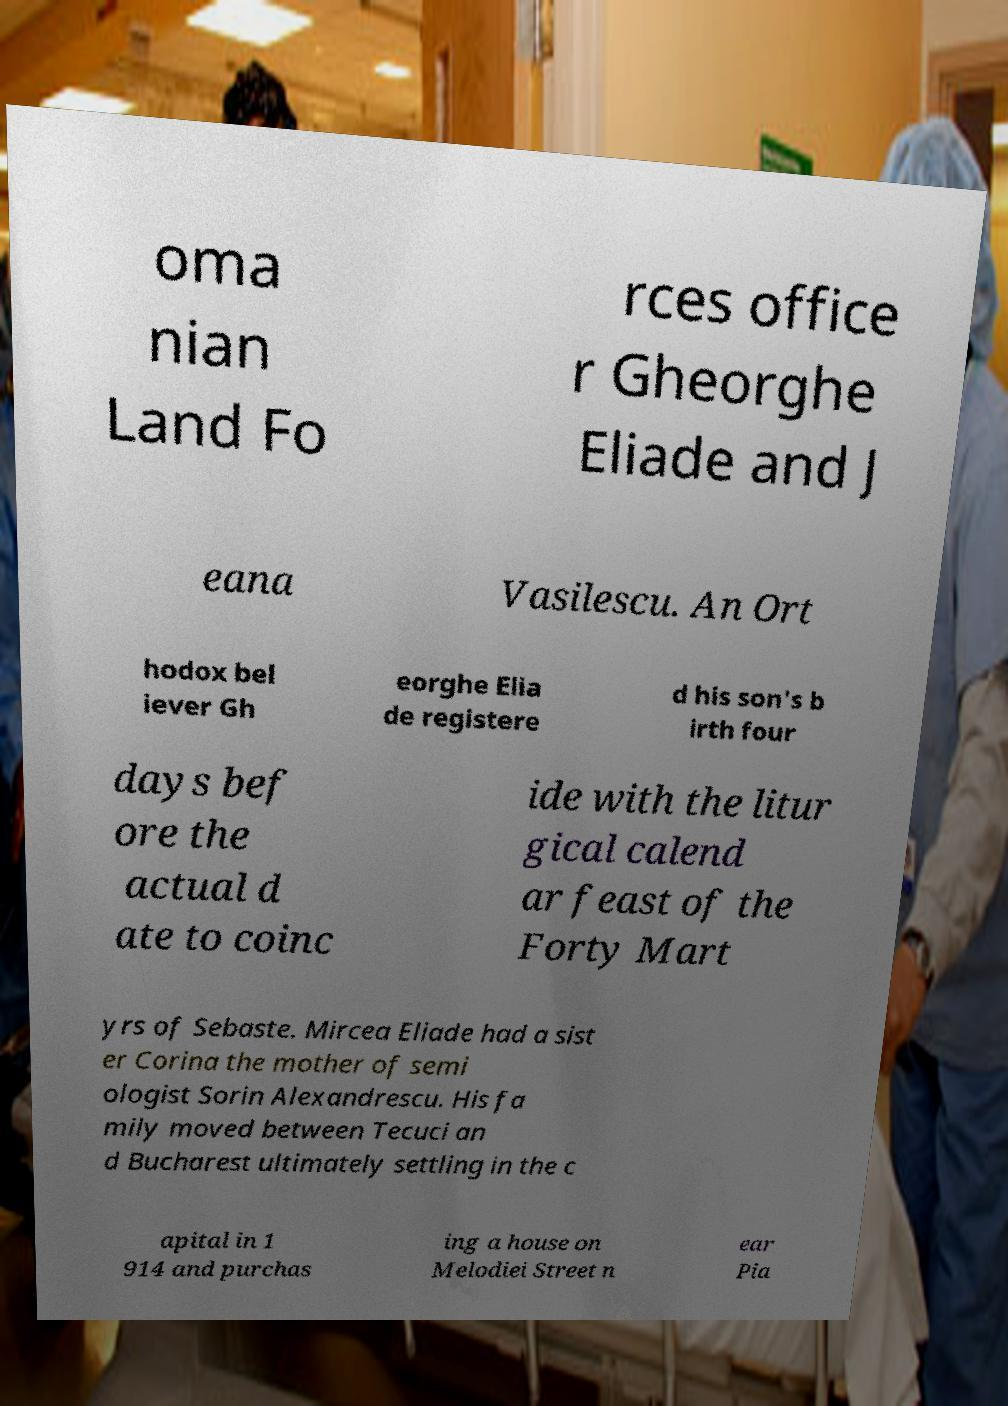There's text embedded in this image that I need extracted. Can you transcribe it verbatim? oma nian Land Fo rces office r Gheorghe Eliade and J eana Vasilescu. An Ort hodox bel iever Gh eorghe Elia de registere d his son's b irth four days bef ore the actual d ate to coinc ide with the litur gical calend ar feast of the Forty Mart yrs of Sebaste. Mircea Eliade had a sist er Corina the mother of semi ologist Sorin Alexandrescu. His fa mily moved between Tecuci an d Bucharest ultimately settling in the c apital in 1 914 and purchas ing a house on Melodiei Street n ear Pia 